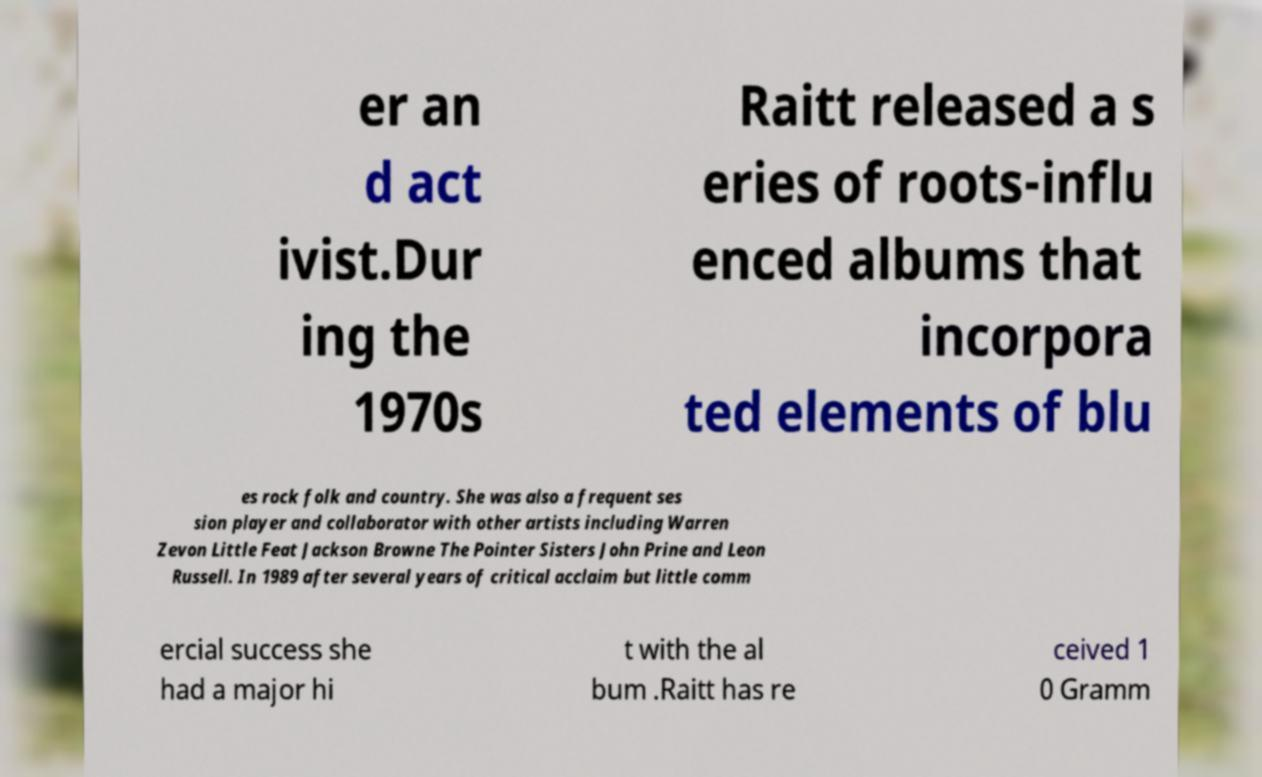Please identify and transcribe the text found in this image. er an d act ivist.Dur ing the 1970s Raitt released a s eries of roots-influ enced albums that incorpora ted elements of blu es rock folk and country. She was also a frequent ses sion player and collaborator with other artists including Warren Zevon Little Feat Jackson Browne The Pointer Sisters John Prine and Leon Russell. In 1989 after several years of critical acclaim but little comm ercial success she had a major hi t with the al bum .Raitt has re ceived 1 0 Gramm 